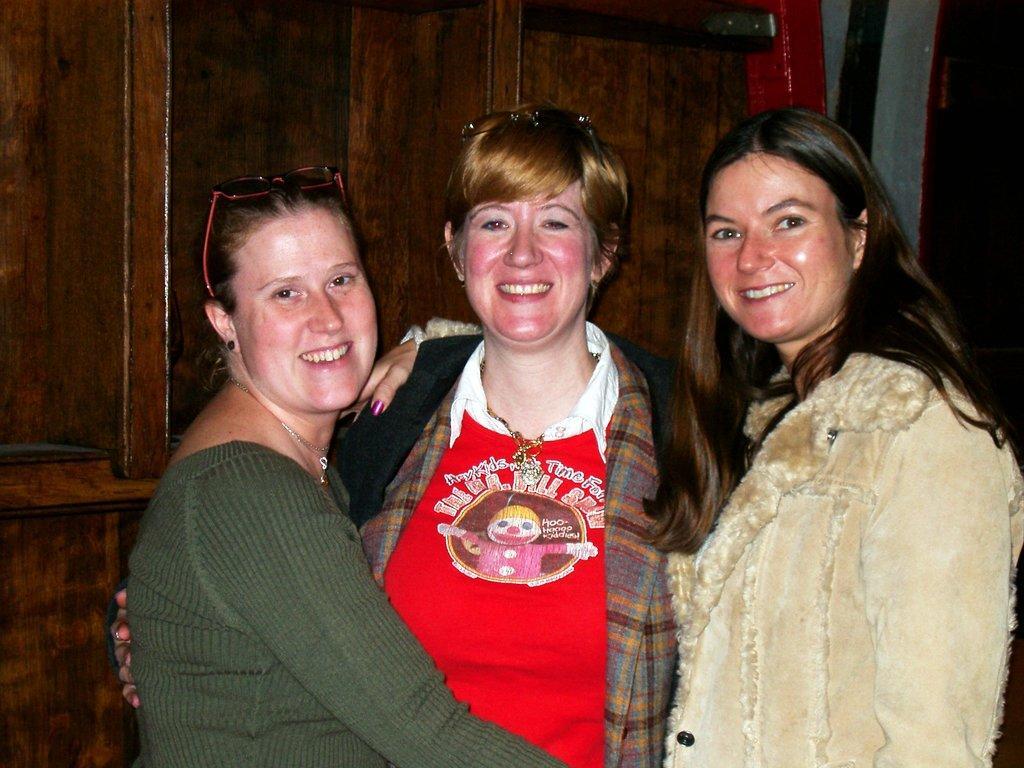Please provide a concise description of this image. In this image, we can see people standing and smiling and in the background, there is a wall and we can see some objects. 